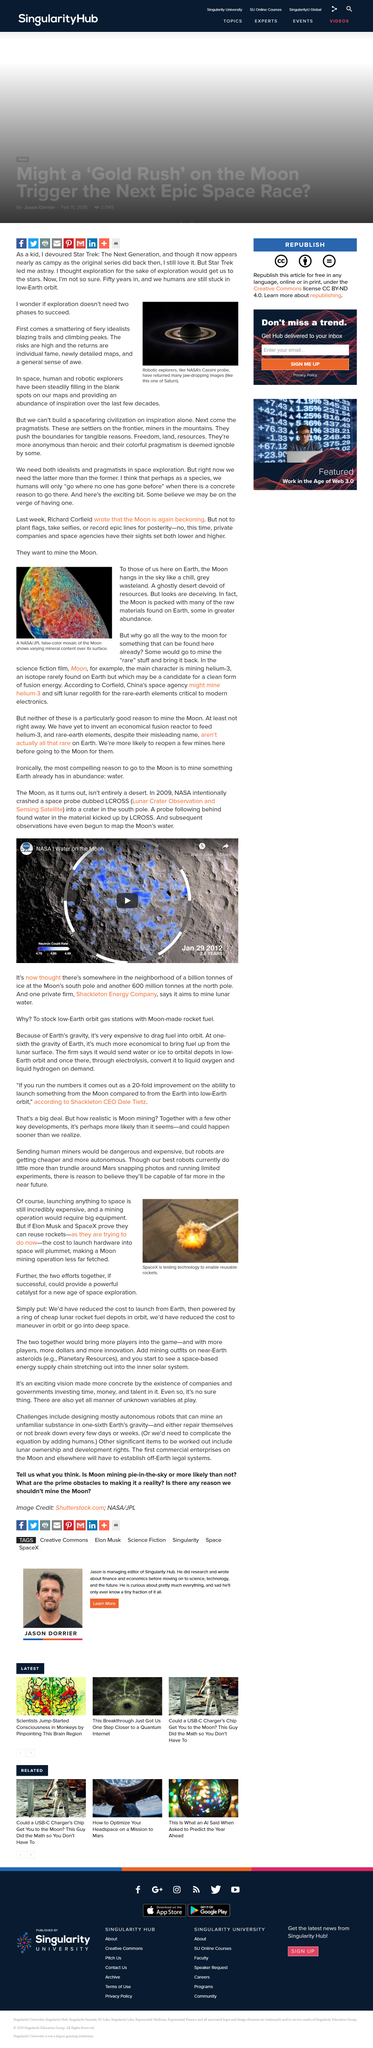Highlight a few significant elements in this photo. If successful, the combined efforts of the SpaceX and Blue Origin proposals could serve as a powerful catalyst for a new era of space exploration, unlocking the potential for humanity to expand its reach beyond the confines of our planet and into the vast expanse of the cosmos. It is a universally accepted fact that humans have not yet reached the stars, despite their continued efforts in space exploration It has come to my attention that there are those who seek to extract resources from the Moon. They have expressed a desire to mine the lunar surface for its valuable materials. SpaceX is currently conducting tests to advance its mission of enabling the reusability of rockets. The reason why people want to mine the Moon is because the Moon contains raw materials that are more abundant than those found on Earth, such as Helium-3, a rare isotope of Helium that is used in nuclear fusion and could be a potential source of clean energy. Additionally, the Moon has significant quantities of other valuable resources, such as titanium, gold, and water, making it an attractive target for mineral extraction. 